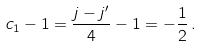<formula> <loc_0><loc_0><loc_500><loc_500>c _ { 1 } - 1 = \frac { j - j ^ { \prime } } { 4 } - 1 = - \frac { 1 } { 2 } \, .</formula> 